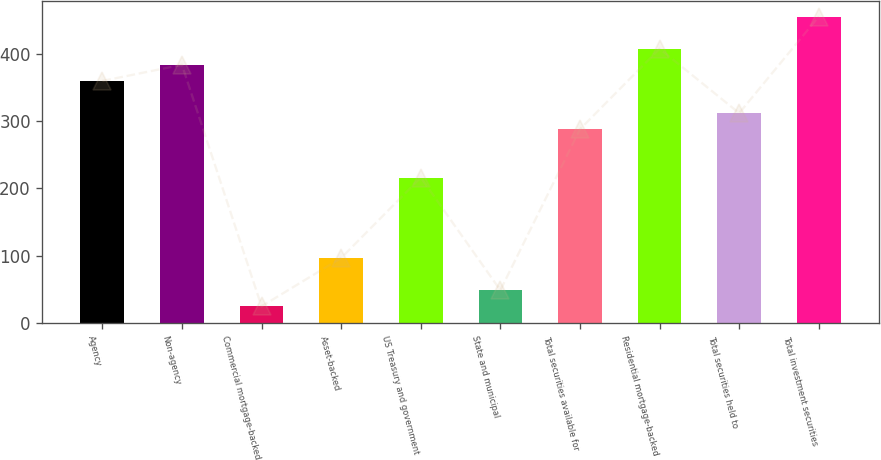Convert chart. <chart><loc_0><loc_0><loc_500><loc_500><bar_chart><fcel>Agency<fcel>Non-agency<fcel>Commercial mortgage-backed<fcel>Asset-backed<fcel>US Treasury and government<fcel>State and municipal<fcel>Total securities available for<fcel>Residential mortgage-backed<fcel>Total securities held to<fcel>Total investment securities<nl><fcel>359.5<fcel>383.4<fcel>24.9<fcel>96.6<fcel>216.1<fcel>48.8<fcel>287.8<fcel>407.3<fcel>311.7<fcel>455.1<nl></chart> 